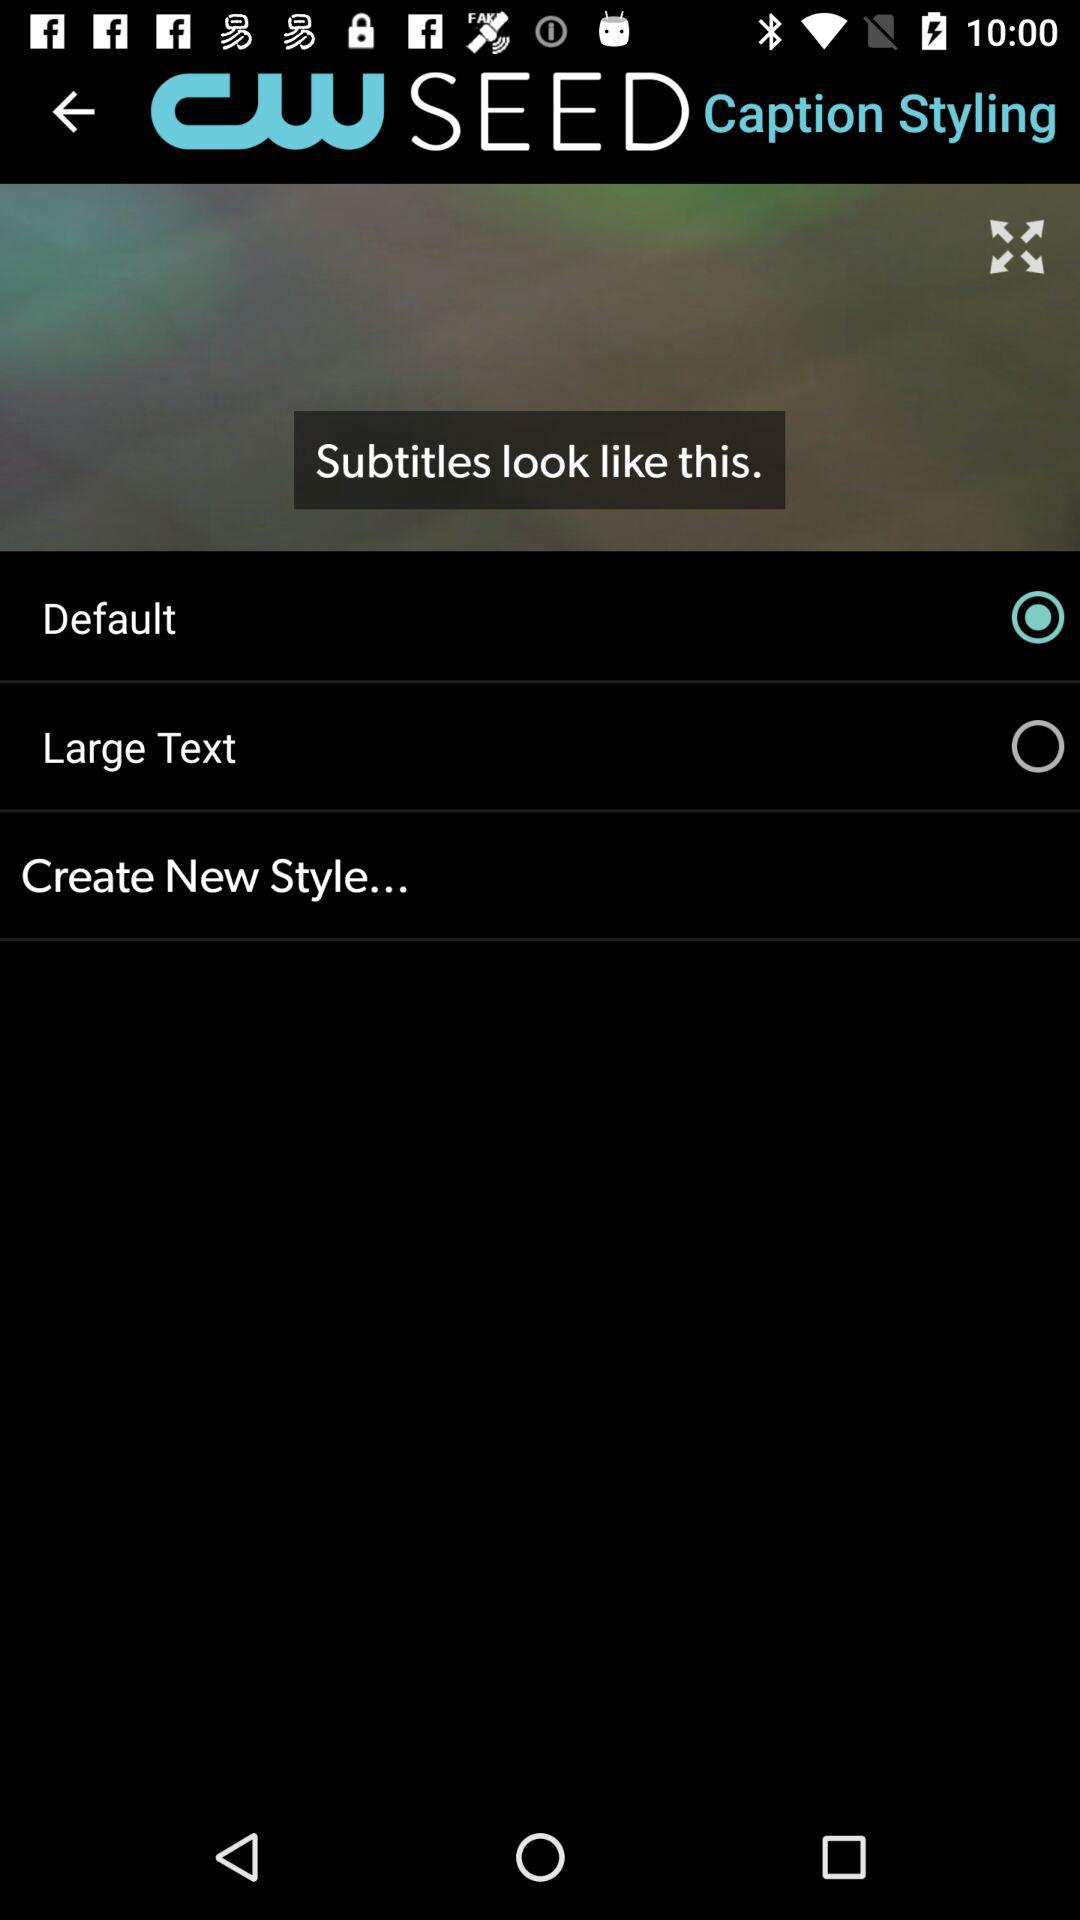What is the name of the application? The name of the application is "CW SEED". 